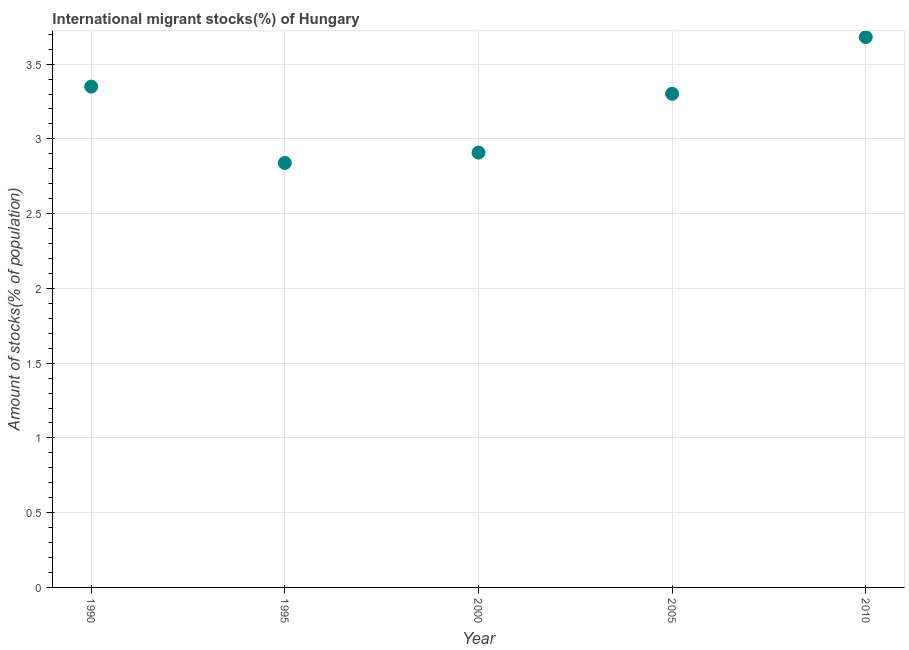What is the number of international migrant stocks in 1995?
Offer a very short reply. 2.84. Across all years, what is the maximum number of international migrant stocks?
Keep it short and to the point. 3.68. Across all years, what is the minimum number of international migrant stocks?
Give a very brief answer. 2.84. In which year was the number of international migrant stocks maximum?
Offer a terse response. 2010. What is the sum of the number of international migrant stocks?
Make the answer very short. 16.08. What is the difference between the number of international migrant stocks in 2005 and 2010?
Provide a succinct answer. -0.38. What is the average number of international migrant stocks per year?
Offer a very short reply. 3.22. What is the median number of international migrant stocks?
Offer a terse response. 3.3. Do a majority of the years between 2005 and 1990 (inclusive) have number of international migrant stocks greater than 1.5 %?
Provide a succinct answer. Yes. What is the ratio of the number of international migrant stocks in 2005 to that in 2010?
Keep it short and to the point. 0.9. Is the difference between the number of international migrant stocks in 1990 and 2010 greater than the difference between any two years?
Offer a very short reply. No. What is the difference between the highest and the second highest number of international migrant stocks?
Provide a short and direct response. 0.33. What is the difference between the highest and the lowest number of international migrant stocks?
Make the answer very short. 0.84. How many dotlines are there?
Provide a short and direct response. 1. How many years are there in the graph?
Your answer should be very brief. 5. What is the title of the graph?
Offer a very short reply. International migrant stocks(%) of Hungary. What is the label or title of the Y-axis?
Your answer should be compact. Amount of stocks(% of population). What is the Amount of stocks(% of population) in 1990?
Offer a terse response. 3.35. What is the Amount of stocks(% of population) in 1995?
Ensure brevity in your answer.  2.84. What is the Amount of stocks(% of population) in 2000?
Offer a very short reply. 2.91. What is the Amount of stocks(% of population) in 2005?
Give a very brief answer. 3.3. What is the Amount of stocks(% of population) in 2010?
Provide a succinct answer. 3.68. What is the difference between the Amount of stocks(% of population) in 1990 and 1995?
Provide a short and direct response. 0.51. What is the difference between the Amount of stocks(% of population) in 1990 and 2000?
Keep it short and to the point. 0.44. What is the difference between the Amount of stocks(% of population) in 1990 and 2005?
Your answer should be very brief. 0.05. What is the difference between the Amount of stocks(% of population) in 1990 and 2010?
Give a very brief answer. -0.33. What is the difference between the Amount of stocks(% of population) in 1995 and 2000?
Give a very brief answer. -0.07. What is the difference between the Amount of stocks(% of population) in 1995 and 2005?
Keep it short and to the point. -0.46. What is the difference between the Amount of stocks(% of population) in 1995 and 2010?
Your response must be concise. -0.84. What is the difference between the Amount of stocks(% of population) in 2000 and 2005?
Keep it short and to the point. -0.39. What is the difference between the Amount of stocks(% of population) in 2000 and 2010?
Your answer should be compact. -0.77. What is the difference between the Amount of stocks(% of population) in 2005 and 2010?
Keep it short and to the point. -0.38. What is the ratio of the Amount of stocks(% of population) in 1990 to that in 1995?
Keep it short and to the point. 1.18. What is the ratio of the Amount of stocks(% of population) in 1990 to that in 2000?
Provide a short and direct response. 1.15. What is the ratio of the Amount of stocks(% of population) in 1990 to that in 2005?
Provide a succinct answer. 1.01. What is the ratio of the Amount of stocks(% of population) in 1990 to that in 2010?
Offer a terse response. 0.91. What is the ratio of the Amount of stocks(% of population) in 1995 to that in 2000?
Keep it short and to the point. 0.98. What is the ratio of the Amount of stocks(% of population) in 1995 to that in 2005?
Offer a very short reply. 0.86. What is the ratio of the Amount of stocks(% of population) in 1995 to that in 2010?
Ensure brevity in your answer.  0.77. What is the ratio of the Amount of stocks(% of population) in 2000 to that in 2005?
Offer a very short reply. 0.88. What is the ratio of the Amount of stocks(% of population) in 2000 to that in 2010?
Your answer should be compact. 0.79. What is the ratio of the Amount of stocks(% of population) in 2005 to that in 2010?
Provide a short and direct response. 0.9. 